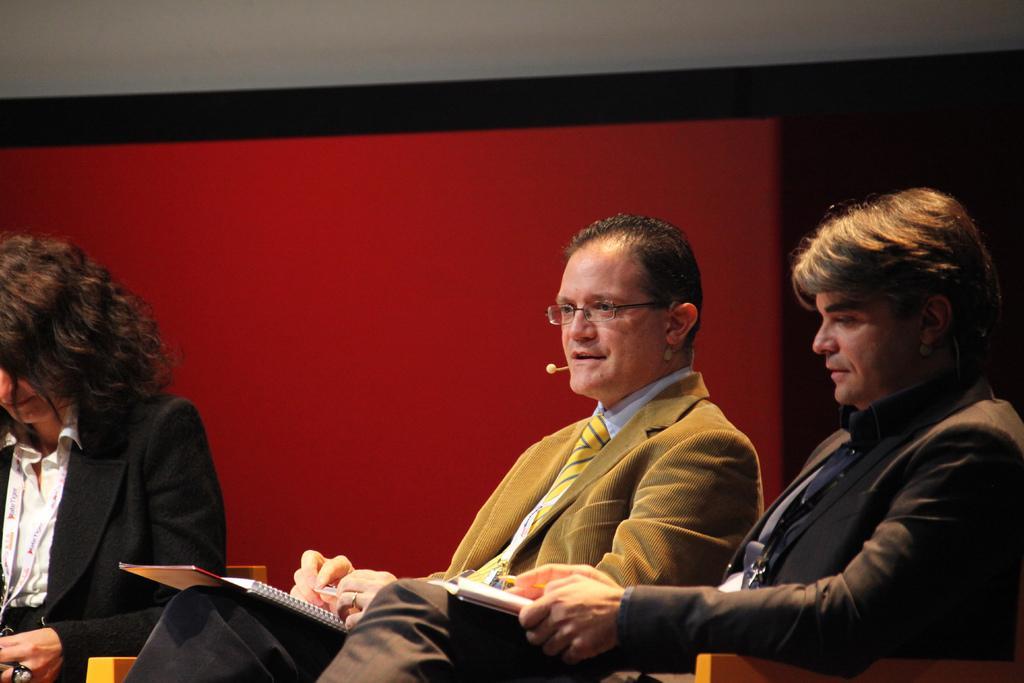Describe this image in one or two sentences. In the image there are two men sitting and holding books in their hands. There is a man with spectacles and mic. On the left side of the image there is a lady. Behind them there is a red and black background. 